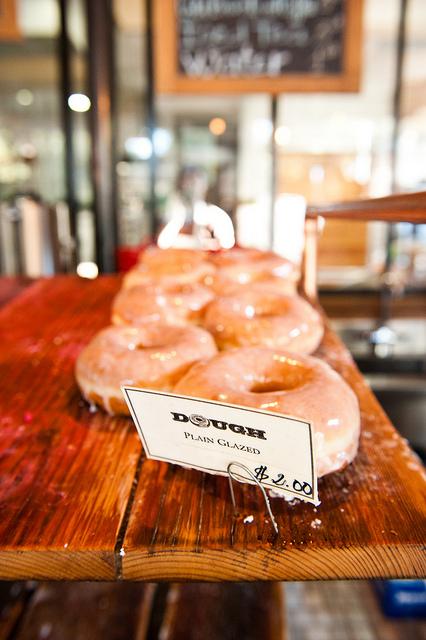How much are the donuts?
Give a very brief answer. 2.00. How many donuts?
Answer briefly. 8. What type of donuts are on display?
Quick response, please. Glazed. Are the donuts on a wooden board?
Short answer required. Yes. 